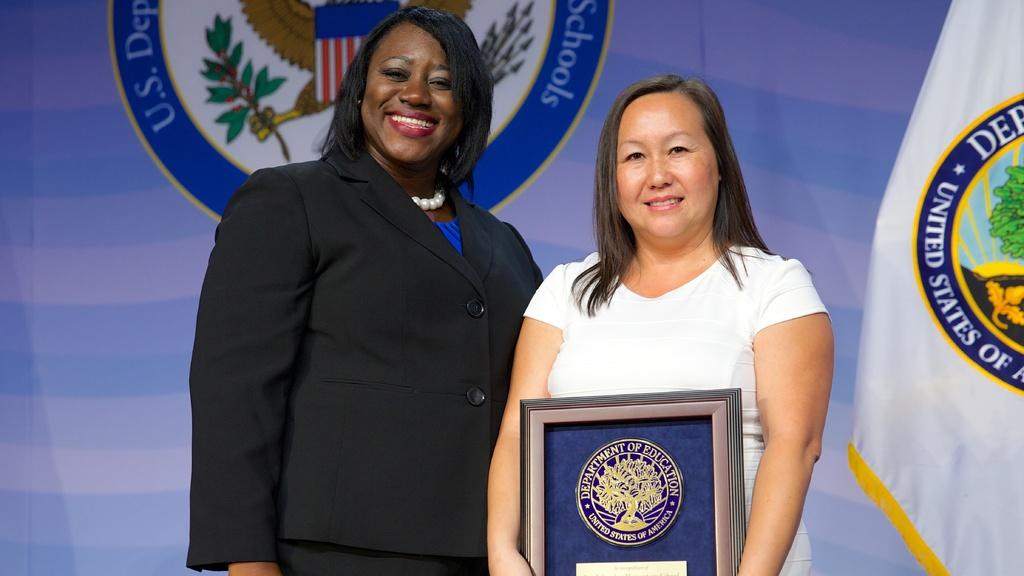Where does this award come from?
Offer a terse response. Department of education. 